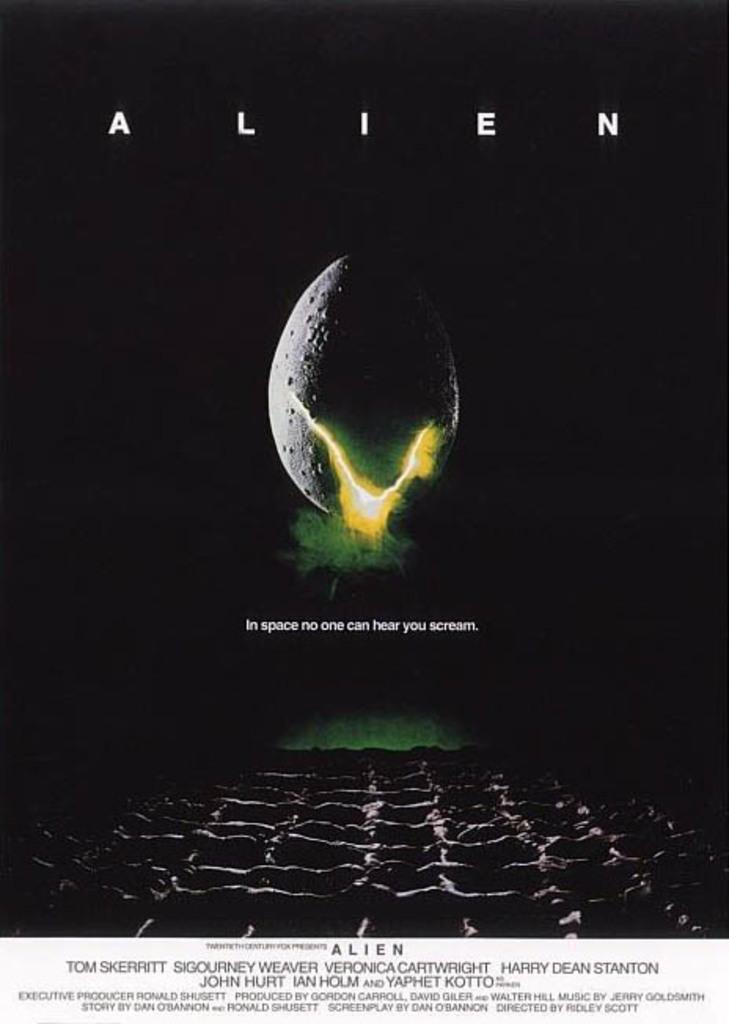<image>
Create a compact narrative representing the image presented. A poster for the movie Alien contains the famous tag line, "In space no one can hear you scream". 